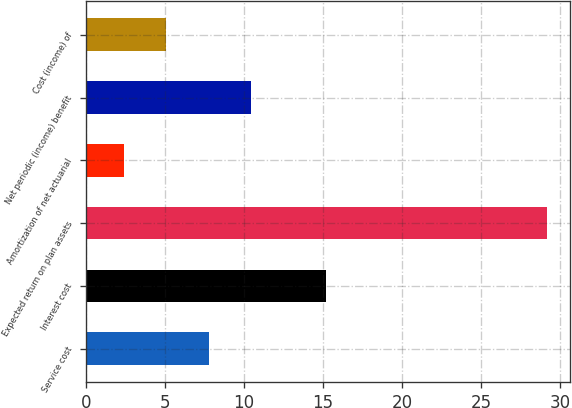<chart> <loc_0><loc_0><loc_500><loc_500><bar_chart><fcel>Service cost<fcel>Interest cost<fcel>Expected return on plan assets<fcel>Amortization of net actuarial<fcel>Net periodic (income) benefit<fcel>Cost (income) of<nl><fcel>7.76<fcel>15.2<fcel>29.2<fcel>2.4<fcel>10.44<fcel>5.08<nl></chart> 